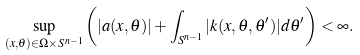<formula> <loc_0><loc_0><loc_500><loc_500>\sup _ { ( x , \theta ) \in \Omega \times S ^ { n - 1 } } \left ( | a ( x , \theta ) | + \int _ { S ^ { n - 1 } } | k ( x , \theta , \theta ^ { \prime } ) | d \theta ^ { \prime } \right ) < \infty .</formula> 